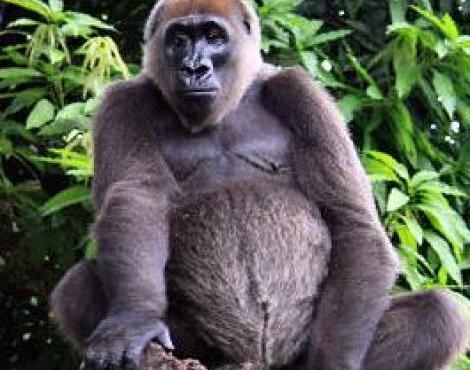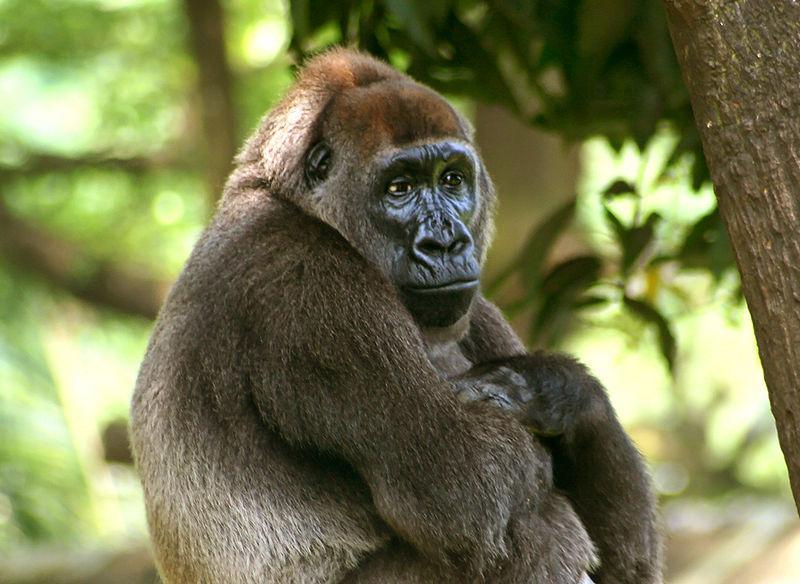The first image is the image on the left, the second image is the image on the right. Evaluate the accuracy of this statement regarding the images: "The primate in the image on the left is an adult, and there is at least one baby primate in the image on the right.". Is it true? Answer yes or no. No. 